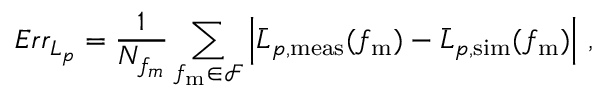Convert formula to latex. <formula><loc_0><loc_0><loc_500><loc_500>E r r _ { L _ { p } } = \frac { 1 } { N _ { f _ { m } } } \sum _ { f _ { m } \in \mathcal { F } } \left | \bar { L } _ { p , m e a s } ( f _ { m } ) - \bar { L } _ { p , s i m } ( f _ { m } ) \right | \, ,</formula> 